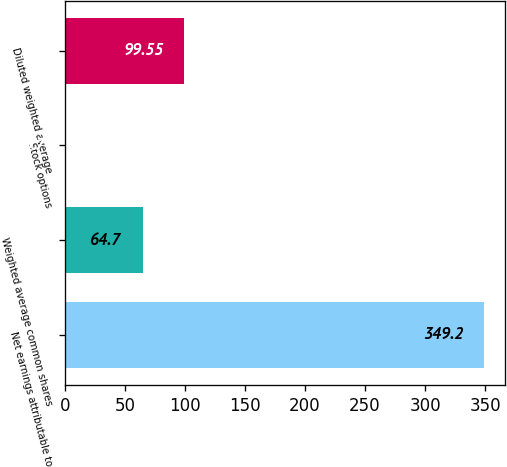<chart> <loc_0><loc_0><loc_500><loc_500><bar_chart><fcel>Net earnings attributable to<fcel>Weighted average common shares<fcel>Stock options<fcel>Diluted weighted average<nl><fcel>349.2<fcel>64.7<fcel>0.7<fcel>99.55<nl></chart> 